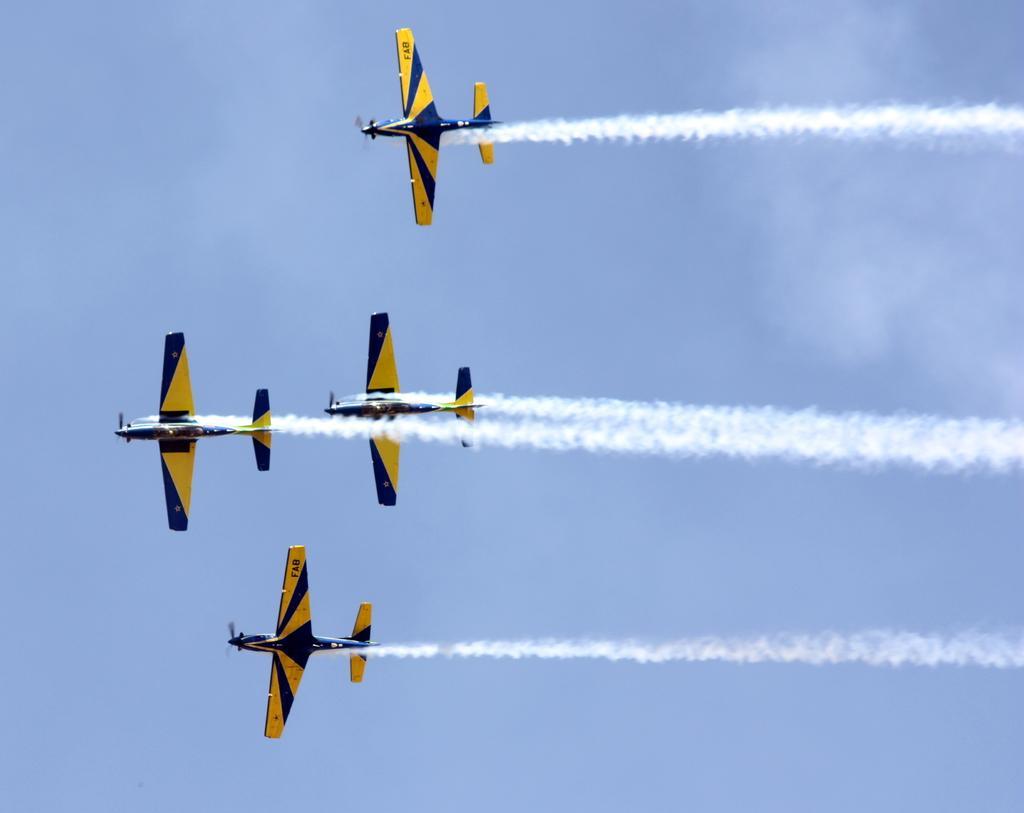Please provide a concise description of this image. In this picture we can see the black and yellow color for aircrafts are flying in the sky. Behind there is a white smoke. 